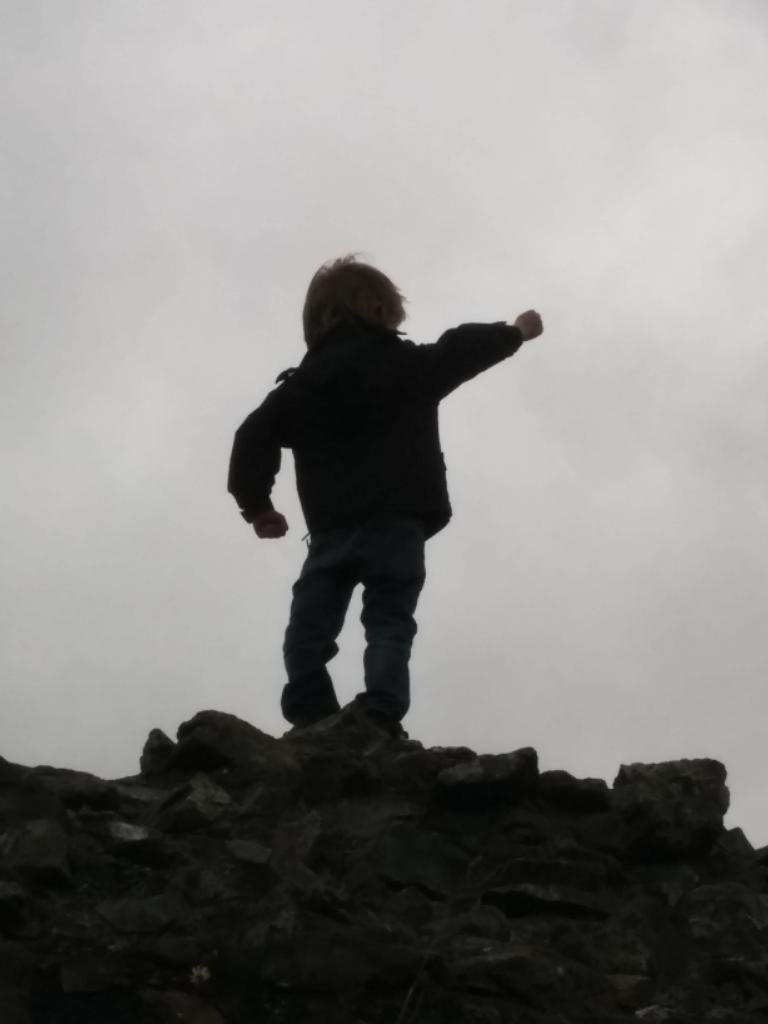What is the main subject of the image? There is a boy in the image. What is the boy doing in the image? The boy is standing. What can be seen in the background of the image? The sky is visible in the image. What type of ornament is the boy holding in the image? There is no ornament present in the image; the boy is simply standing. 